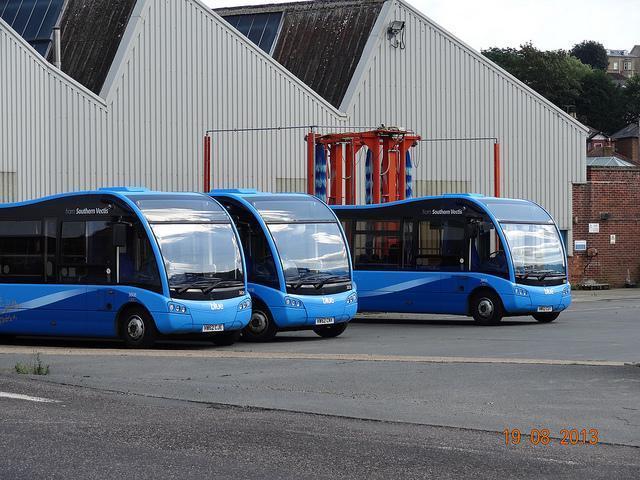How many angles are on the roof of the building?
Give a very brief answer. 3. How many buses can be seen?
Give a very brief answer. 3. 